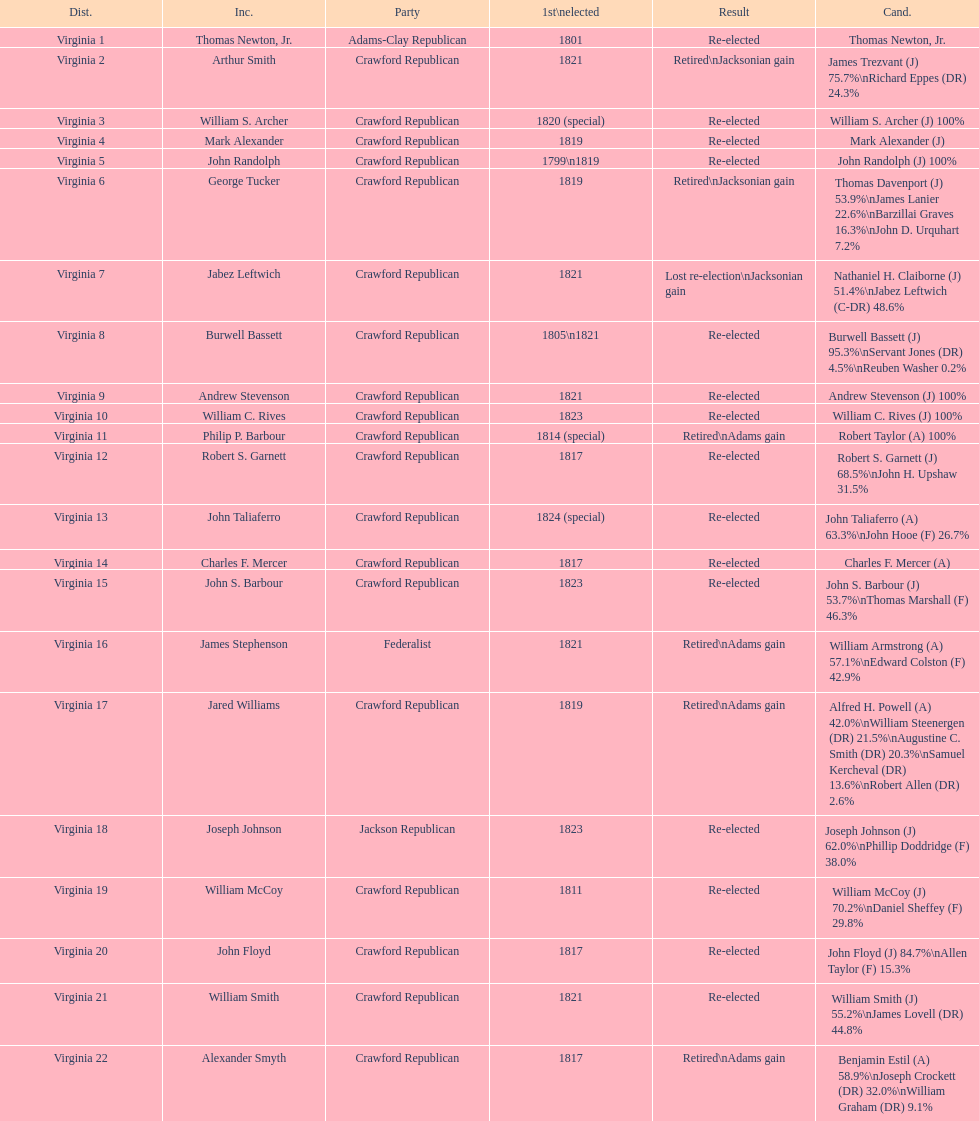Parse the table in full. {'header': ['Dist.', 'Inc.', 'Party', '1st\\nelected', 'Result', 'Cand.'], 'rows': [['Virginia 1', 'Thomas Newton, Jr.', 'Adams-Clay Republican', '1801', 'Re-elected', 'Thomas Newton, Jr.'], ['Virginia 2', 'Arthur Smith', 'Crawford Republican', '1821', 'Retired\\nJacksonian gain', 'James Trezvant (J) 75.7%\\nRichard Eppes (DR) 24.3%'], ['Virginia 3', 'William S. Archer', 'Crawford Republican', '1820 (special)', 'Re-elected', 'William S. Archer (J) 100%'], ['Virginia 4', 'Mark Alexander', 'Crawford Republican', '1819', 'Re-elected', 'Mark Alexander (J)'], ['Virginia 5', 'John Randolph', 'Crawford Republican', '1799\\n1819', 'Re-elected', 'John Randolph (J) 100%'], ['Virginia 6', 'George Tucker', 'Crawford Republican', '1819', 'Retired\\nJacksonian gain', 'Thomas Davenport (J) 53.9%\\nJames Lanier 22.6%\\nBarzillai Graves 16.3%\\nJohn D. Urquhart 7.2%'], ['Virginia 7', 'Jabez Leftwich', 'Crawford Republican', '1821', 'Lost re-election\\nJacksonian gain', 'Nathaniel H. Claiborne (J) 51.4%\\nJabez Leftwich (C-DR) 48.6%'], ['Virginia 8', 'Burwell Bassett', 'Crawford Republican', '1805\\n1821', 'Re-elected', 'Burwell Bassett (J) 95.3%\\nServant Jones (DR) 4.5%\\nReuben Washer 0.2%'], ['Virginia 9', 'Andrew Stevenson', 'Crawford Republican', '1821', 'Re-elected', 'Andrew Stevenson (J) 100%'], ['Virginia 10', 'William C. Rives', 'Crawford Republican', '1823', 'Re-elected', 'William C. Rives (J) 100%'], ['Virginia 11', 'Philip P. Barbour', 'Crawford Republican', '1814 (special)', 'Retired\\nAdams gain', 'Robert Taylor (A) 100%'], ['Virginia 12', 'Robert S. Garnett', 'Crawford Republican', '1817', 'Re-elected', 'Robert S. Garnett (J) 68.5%\\nJohn H. Upshaw 31.5%'], ['Virginia 13', 'John Taliaferro', 'Crawford Republican', '1824 (special)', 'Re-elected', 'John Taliaferro (A) 63.3%\\nJohn Hooe (F) 26.7%'], ['Virginia 14', 'Charles F. Mercer', 'Crawford Republican', '1817', 'Re-elected', 'Charles F. Mercer (A)'], ['Virginia 15', 'John S. Barbour', 'Crawford Republican', '1823', 'Re-elected', 'John S. Barbour (J) 53.7%\\nThomas Marshall (F) 46.3%'], ['Virginia 16', 'James Stephenson', 'Federalist', '1821', 'Retired\\nAdams gain', 'William Armstrong (A) 57.1%\\nEdward Colston (F) 42.9%'], ['Virginia 17', 'Jared Williams', 'Crawford Republican', '1819', 'Retired\\nAdams gain', 'Alfred H. Powell (A) 42.0%\\nWilliam Steenergen (DR) 21.5%\\nAugustine C. Smith (DR) 20.3%\\nSamuel Kercheval (DR) 13.6%\\nRobert Allen (DR) 2.6%'], ['Virginia 18', 'Joseph Johnson', 'Jackson Republican', '1823', 'Re-elected', 'Joseph Johnson (J) 62.0%\\nPhillip Doddridge (F) 38.0%'], ['Virginia 19', 'William McCoy', 'Crawford Republican', '1811', 'Re-elected', 'William McCoy (J) 70.2%\\nDaniel Sheffey (F) 29.8%'], ['Virginia 20', 'John Floyd', 'Crawford Republican', '1817', 'Re-elected', 'John Floyd (J) 84.7%\\nAllen Taylor (F) 15.3%'], ['Virginia 21', 'William Smith', 'Crawford Republican', '1821', 'Re-elected', 'William Smith (J) 55.2%\\nJames Lovell (DR) 44.8%'], ['Virginia 22', 'Alexander Smyth', 'Crawford Republican', '1817', 'Retired\\nAdams gain', 'Benjamin Estil (A) 58.9%\\nJoseph Crockett (DR) 32.0%\\nWilliam Graham (DR) 9.1%']]} What is the last party on this chart? Crawford Republican. 